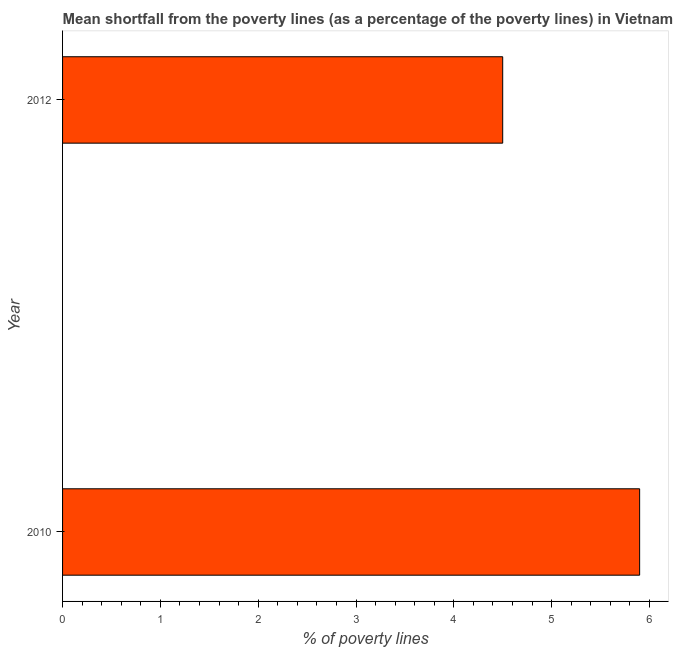Does the graph contain any zero values?
Offer a very short reply. No. Does the graph contain grids?
Offer a very short reply. No. What is the title of the graph?
Your response must be concise. Mean shortfall from the poverty lines (as a percentage of the poverty lines) in Vietnam. What is the label or title of the X-axis?
Provide a short and direct response. % of poverty lines. Across all years, what is the maximum poverty gap at national poverty lines?
Give a very brief answer. 5.9. What is the average poverty gap at national poverty lines per year?
Offer a very short reply. 5.2. In how many years, is the poverty gap at national poverty lines greater than 4 %?
Offer a very short reply. 2. Do a majority of the years between 2010 and 2012 (inclusive) have poverty gap at national poverty lines greater than 2 %?
Ensure brevity in your answer.  Yes. What is the ratio of the poverty gap at national poverty lines in 2010 to that in 2012?
Your answer should be compact. 1.31. Is the poverty gap at national poverty lines in 2010 less than that in 2012?
Your answer should be very brief. No. In how many years, is the poverty gap at national poverty lines greater than the average poverty gap at national poverty lines taken over all years?
Provide a succinct answer. 1. What is the difference between two consecutive major ticks on the X-axis?
Offer a terse response. 1. Are the values on the major ticks of X-axis written in scientific E-notation?
Offer a terse response. No. What is the % of poverty lines of 2010?
Keep it short and to the point. 5.9. What is the % of poverty lines in 2012?
Provide a succinct answer. 4.5. What is the ratio of the % of poverty lines in 2010 to that in 2012?
Ensure brevity in your answer.  1.31. 